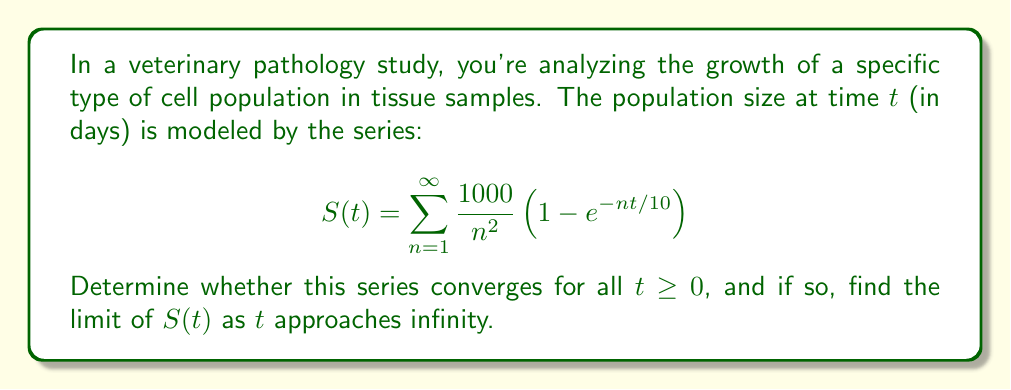Solve this math problem. To determine the convergence of this series and find its limit as $t$ approaches infinity, we'll follow these steps:

1) First, let's examine the general term of the series:

   $$a_n(t) = \frac{1000}{n^2} \left(1 - e^{-nt/10}\right)$$

2) For any fixed $t \geq 0$, we can see that $0 \leq 1 - e^{-nt/10} \leq 1$. Therefore,

   $$0 \leq \frac{1000}{n^2} \left(1 - e^{-nt/10}\right) \leq \frac{1000}{n^2}$$

3) We know that $\sum_{n=1}^{\infty} \frac{1000}{n^2}$ converges (it's a constant multiple of the p-series with p=2). By the comparison test, our series $S(t)$ also converges for all $t \geq 0$.

4) To find the limit as $t$ approaches infinity, we can use the dominated convergence theorem:

   $$\lim_{t \to \infty} S(t) = \sum_{n=1}^{\infty} \lim_{t \to \infty} \frac{1000}{n^2} \left(1 - e^{-nt/10}\right)$$

5) For each $n$, $\lim_{t \to \infty} \left(1 - e^{-nt/10}\right) = 1$

6) Therefore,

   $$\lim_{t \to \infty} S(t) = \sum_{n=1}^{\infty} \frac{1000}{n^2} = 1000 \sum_{n=1}^{\infty} \frac{1}{n^2}$$

7) We know that $\sum_{n=1}^{\infty} \frac{1}{n^2} = \frac{\pi^2}{6}$ (this is a well-known result involving the Riemann zeta function)

8) Thus, the final limit is:

   $$\lim_{t \to \infty} S(t) = 1000 \cdot \frac{\pi^2}{6} \approx 1644.93$$
Answer: The series converges for all $t \geq 0$. The limit of $S(t)$ as $t$ approaches infinity is $\frac{1000\pi^2}{6} \approx 1644.93$. 